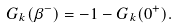<formula> <loc_0><loc_0><loc_500><loc_500>G _ { k } ( \beta ^ { - } ) = - 1 - G _ { k } ( 0 ^ { + } ) .</formula> 